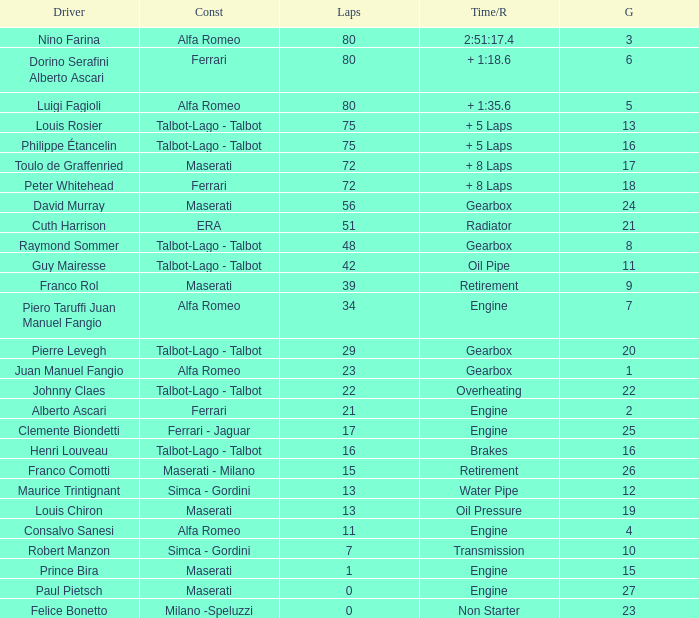When the driver is Juan Manuel Fangio and laps is less than 39, what is the highest grid? 1.0. 